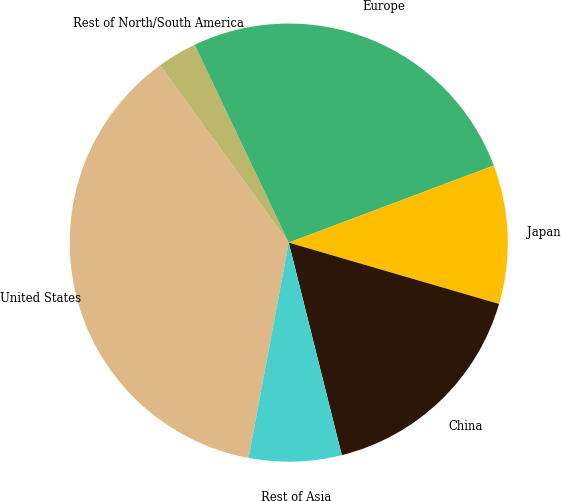Convert chart. <chart><loc_0><loc_0><loc_500><loc_500><pie_chart><fcel>United States<fcel>Rest of North/South America<fcel>Europe<fcel>Japan<fcel>China<fcel>Rest of Asia<nl><fcel>37.07%<fcel>2.93%<fcel>26.34%<fcel>10.24%<fcel>16.59%<fcel>6.83%<nl></chart> 